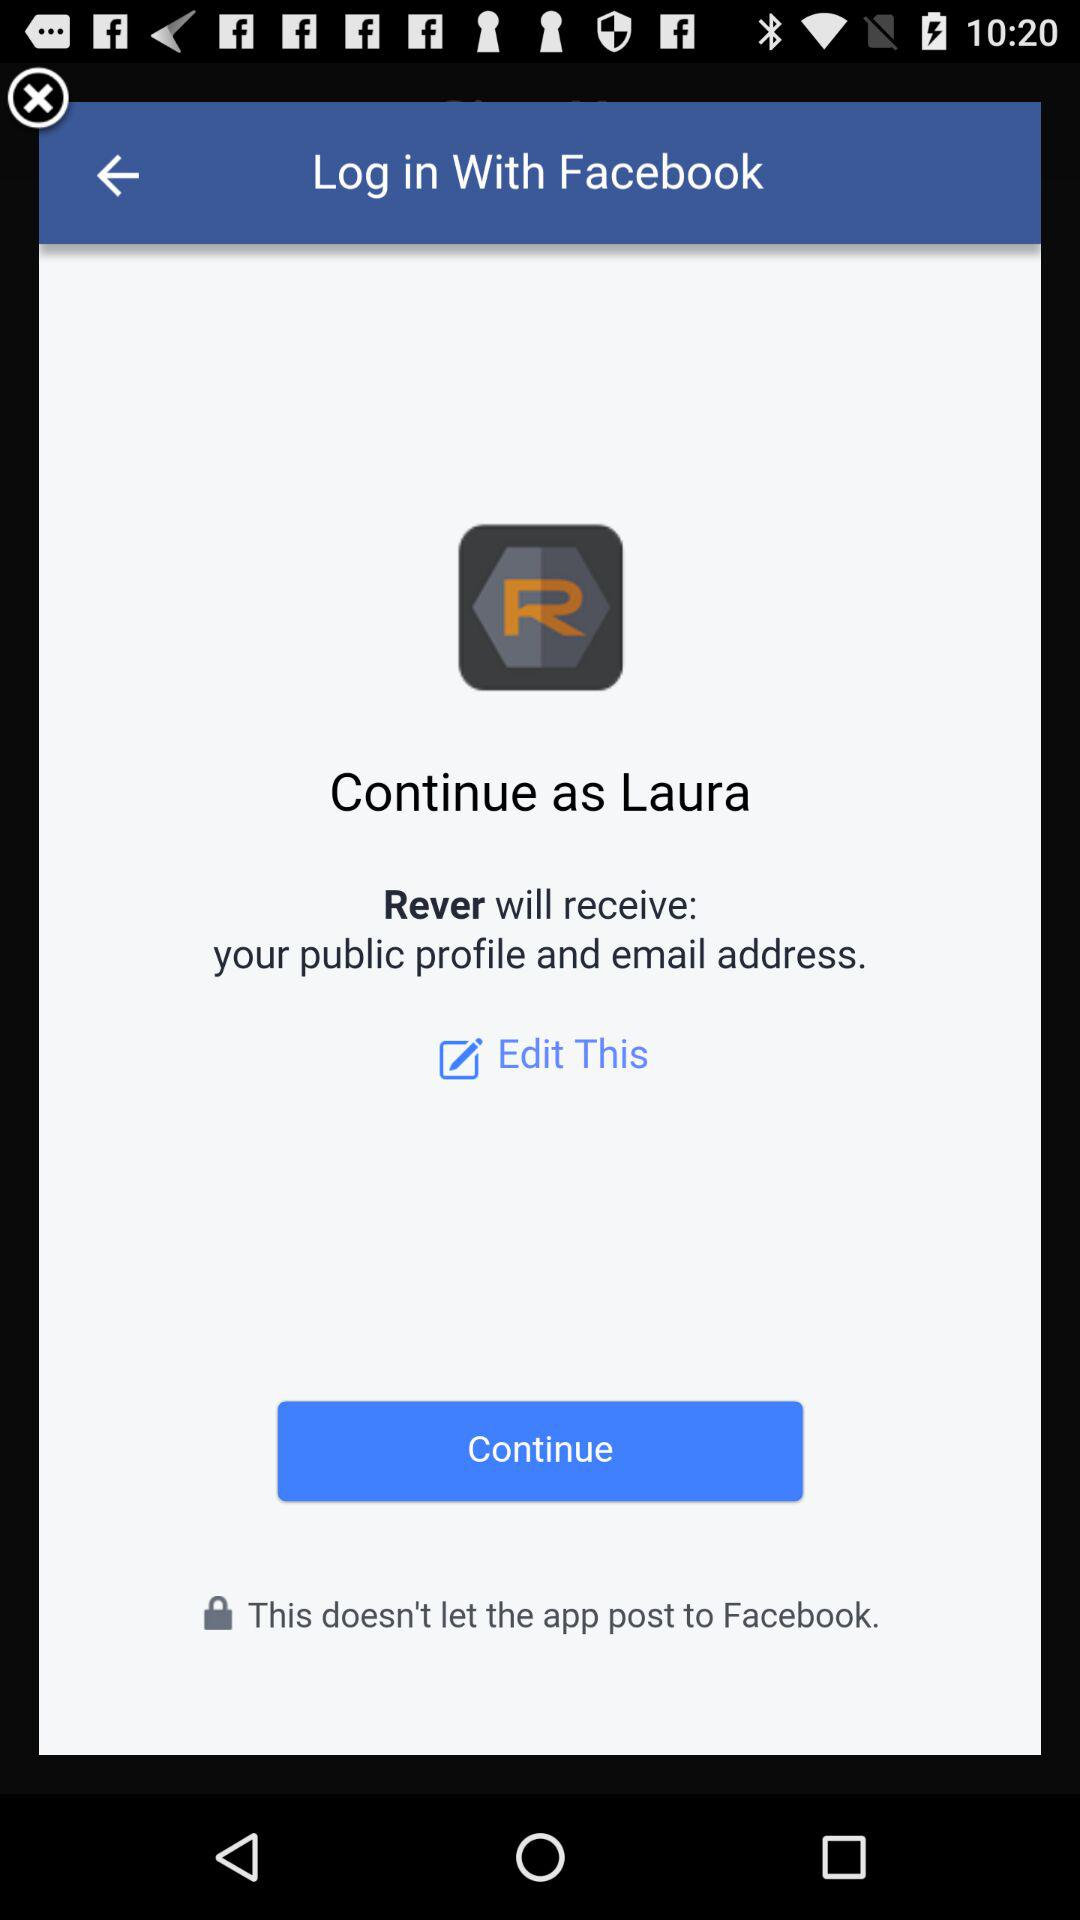What application is asking for permission? The application name is "Rever". 